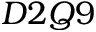Convert formula to latex. <formula><loc_0><loc_0><loc_500><loc_500>D 2 Q 9</formula> 